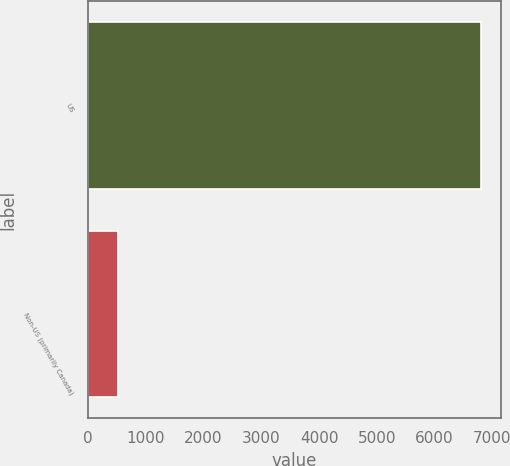Convert chart to OTSL. <chart><loc_0><loc_0><loc_500><loc_500><bar_chart><fcel>US<fcel>Non-US (primarily Canada)<nl><fcel>6807.7<fcel>523.8<nl></chart> 